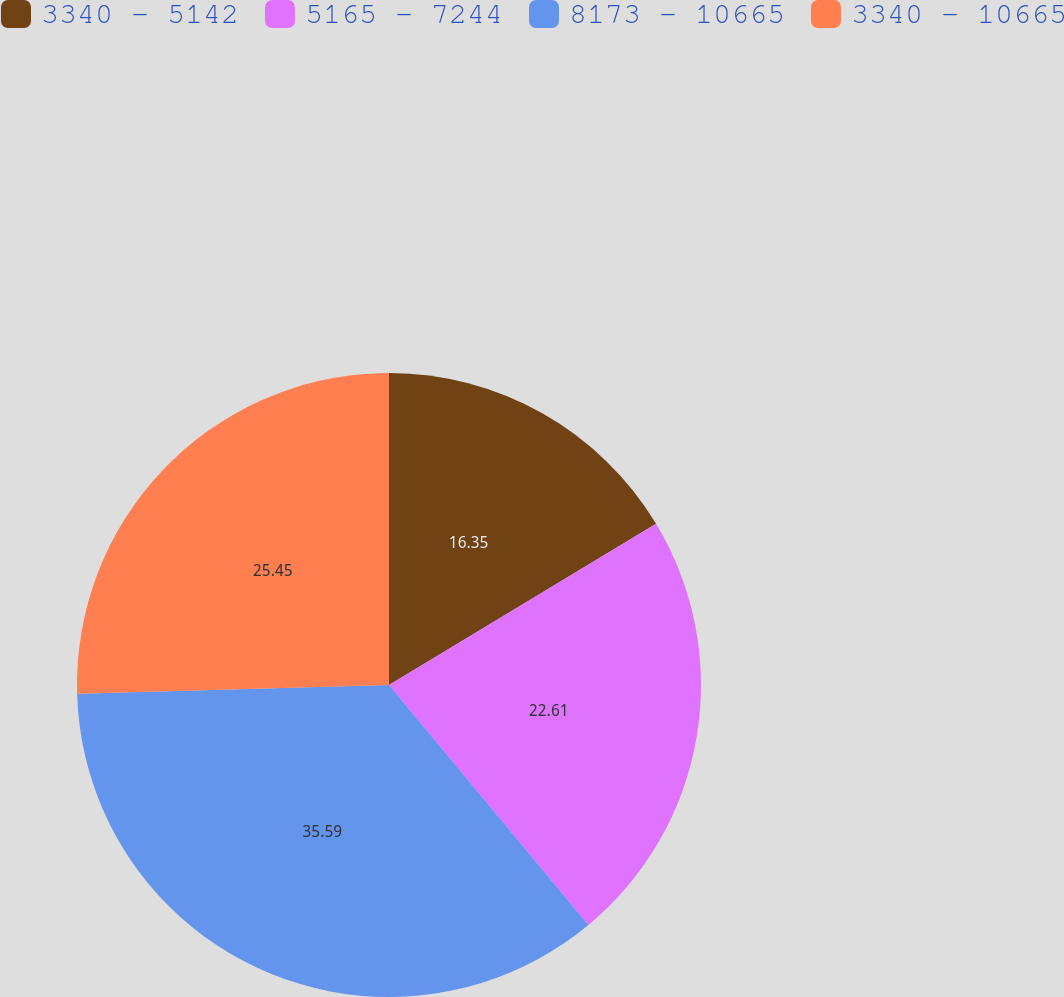<chart> <loc_0><loc_0><loc_500><loc_500><pie_chart><fcel>3340 - 5142<fcel>5165 - 7244<fcel>8173 - 10665<fcel>3340 - 10665<nl><fcel>16.35%<fcel>22.61%<fcel>35.58%<fcel>25.45%<nl></chart> 